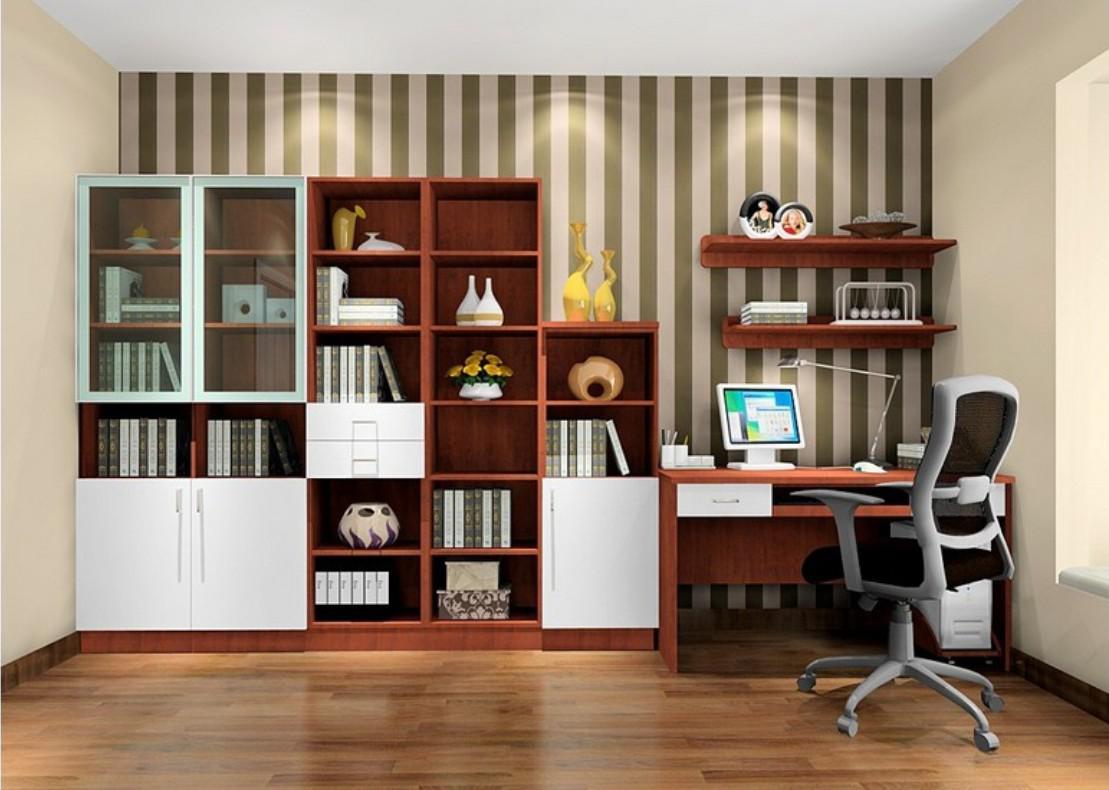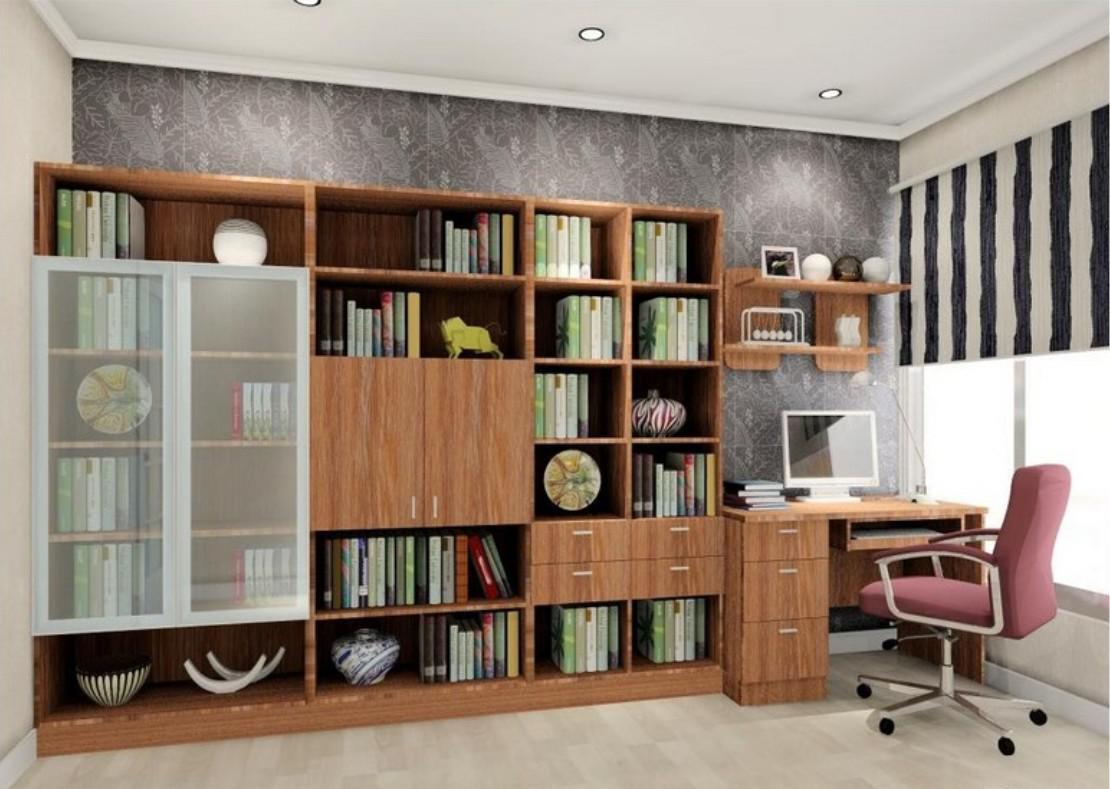The first image is the image on the left, the second image is the image on the right. Analyze the images presented: Is the assertion "The left image shows at least one chair in front of a pair of windows with a blue glow, and shelving along one wall." valid? Answer yes or no. No. The first image is the image on the left, the second image is the image on the right. Examine the images to the left and right. Is the description "THere are at least three floating bookshelves next to a twin bed." accurate? Answer yes or no. No. 